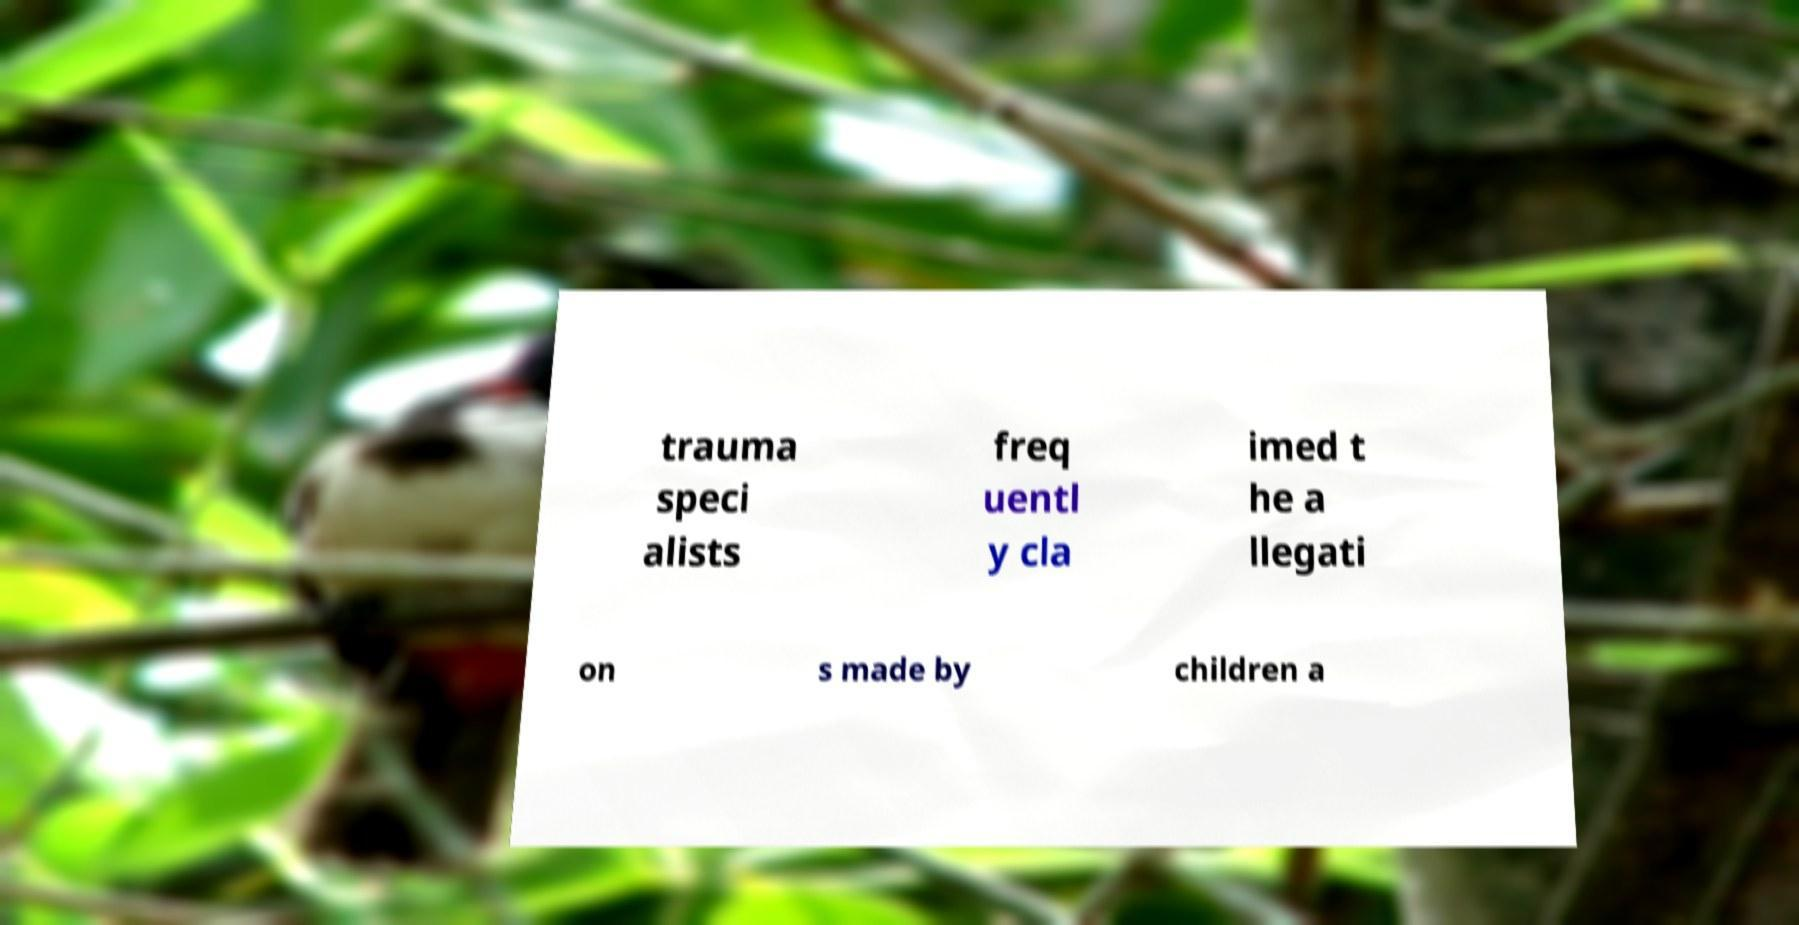There's text embedded in this image that I need extracted. Can you transcribe it verbatim? trauma speci alists freq uentl y cla imed t he a llegati on s made by children a 